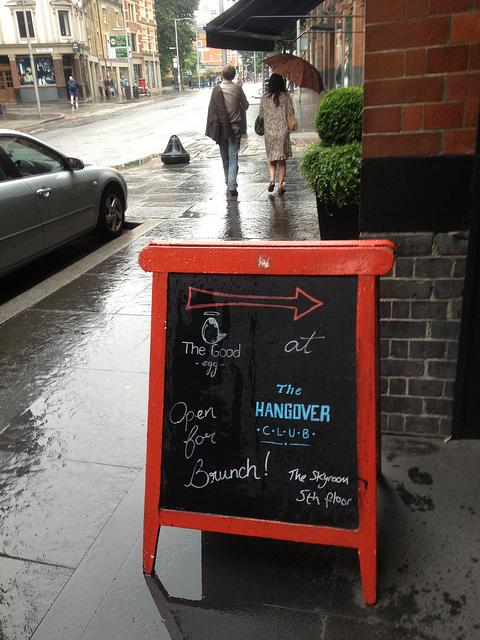Which way is the arrow pointing?
Concise answer only. Right. What kind of club is this?
Concise answer only. Bar. What color is the car on the street?
Quick response, please. Silver. What color is the border of the sign?
Write a very short answer. Red. 